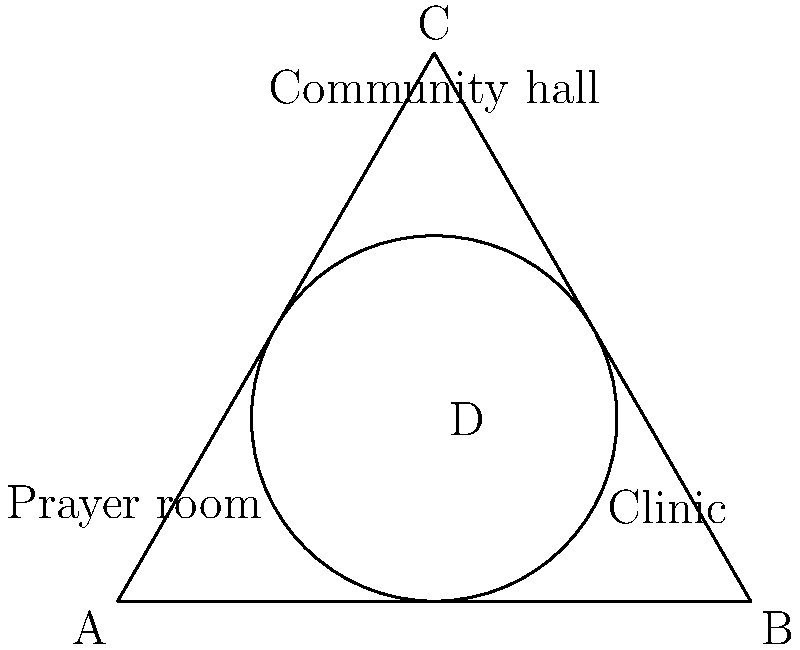In the topological representation of shared community service spaces, a triangle ABC represents the overall area, with an inscribed circle centered at point D. If the circle represents a common meeting area, and each vertex of the triangle represents a specific service space (A: prayer room, B: clinic, C: community hall), what is the minimum number of edges that need to be traversed to visit all three service spaces, starting and ending at the common meeting area (point D)? To solve this problem, we need to understand the topological relationships between the spaces:

1. The circle (common meeting area) is inscribed in the triangle, touching all three sides.
2. Each vertex of the triangle represents a specific service space.
3. Point D (center of the circle) represents the common meeting area.

Now, let's determine the minimum number of edges to traverse:

1. Start at point D (common meeting area).
2. Move to any vertex (e.g., A - prayer room). This counts as 1 edge.
3. From A, move to B (clinic) along the edge AB. This counts as 1 edge.
4. From B, move to C (community hall) along the edge BC. This counts as 1 edge.
5. From C, return to point D (common meeting area). This counts as 1 edge.

In total, we have traversed 4 edges to visit all three service spaces and return to the common meeting area.

It's important to note that this is the minimum number of edges because:
- We cannot visit more than one vertex directly from point D without increasing the number of edges.
- We must visit all three vertices to cover all service spaces.
- We need to return to the starting point (D) to complete the circuit.

Therefore, the minimum number of edges that need to be traversed is 4.
Answer: 4 edges 